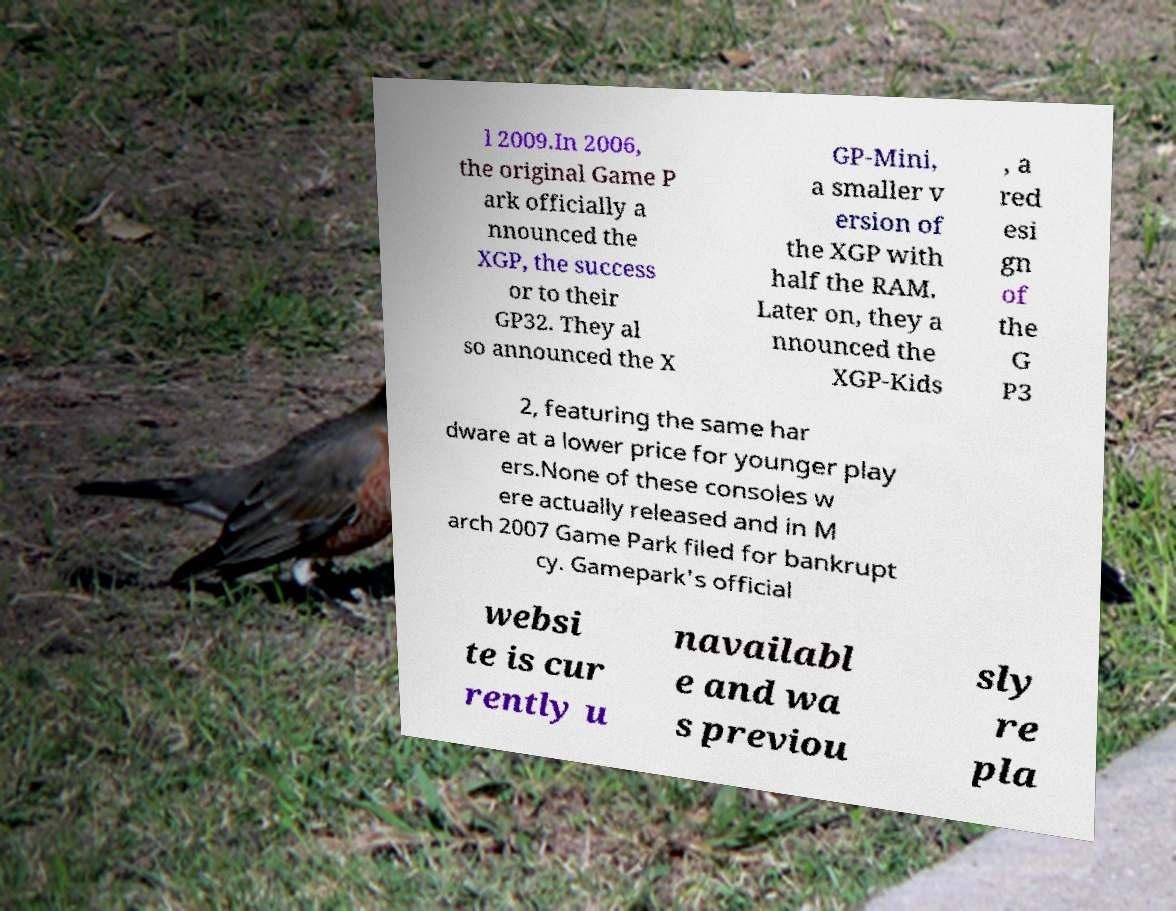There's text embedded in this image that I need extracted. Can you transcribe it verbatim? l 2009.In 2006, the original Game P ark officially a nnounced the XGP, the success or to their GP32. They al so announced the X GP-Mini, a smaller v ersion of the XGP with half the RAM. Later on, they a nnounced the XGP-Kids , a red esi gn of the G P3 2, featuring the same har dware at a lower price for younger play ers.None of these consoles w ere actually released and in M arch 2007 Game Park filed for bankrupt cy. Gamepark's official websi te is cur rently u navailabl e and wa s previou sly re pla 